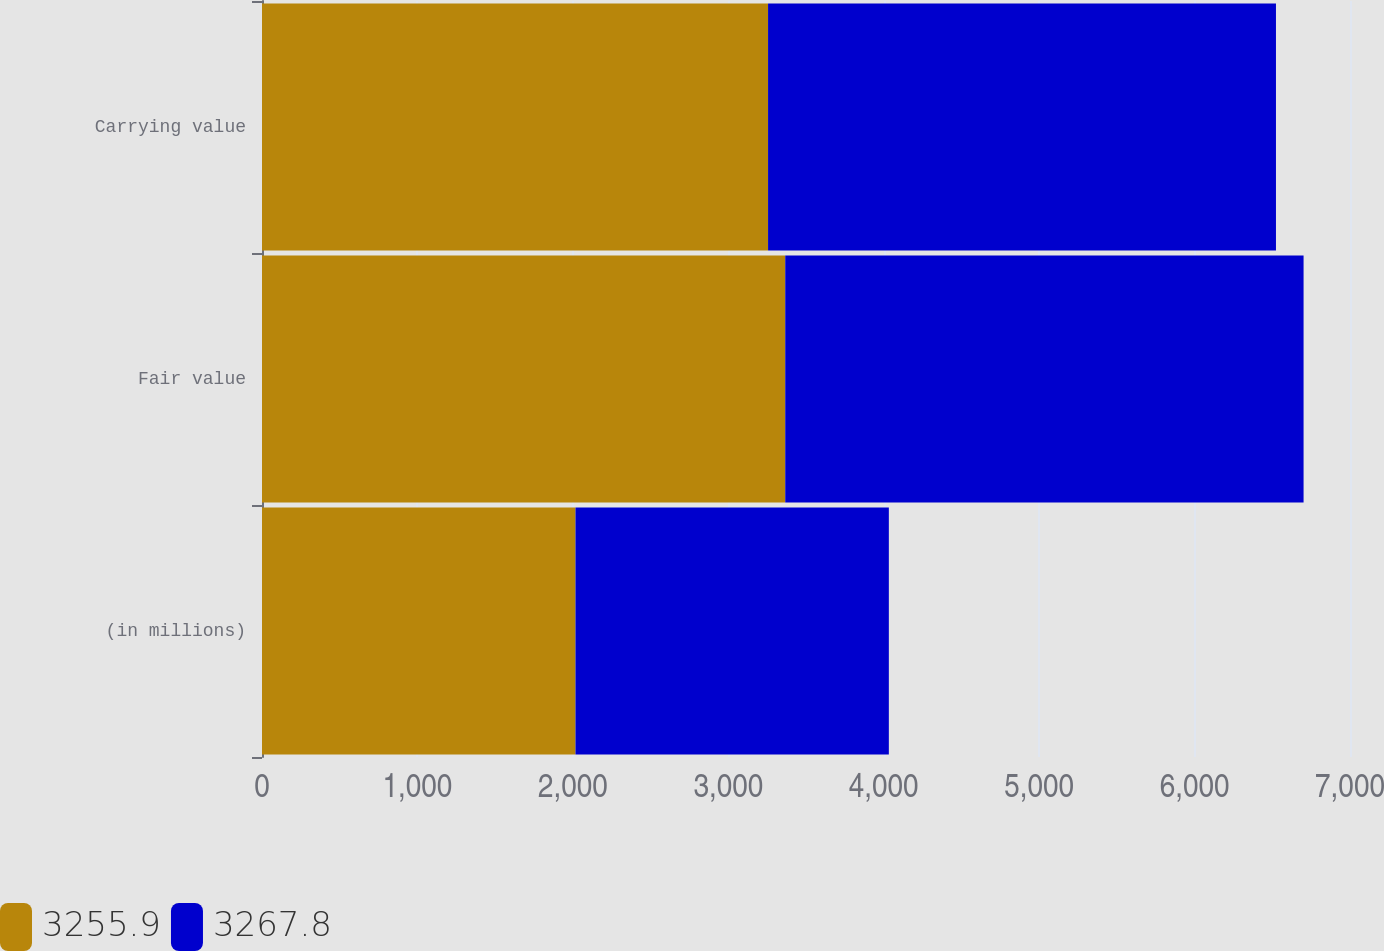Convert chart to OTSL. <chart><loc_0><loc_0><loc_500><loc_500><stacked_bar_chart><ecel><fcel>(in millions)<fcel>Fair value<fcel>Carrying value<nl><fcel>3255.9<fcel>2017<fcel>3366.5<fcel>3255.9<nl><fcel>3267.8<fcel>2016<fcel>3334.8<fcel>3267.8<nl></chart> 